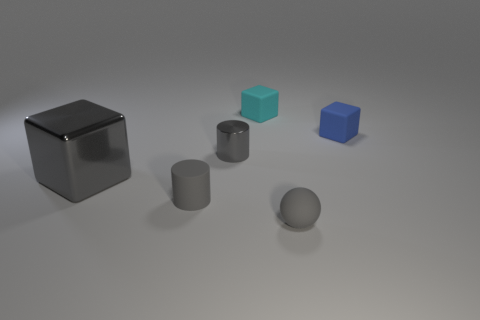There is a shiny block that is the same color as the tiny matte cylinder; what size is it?
Offer a terse response. Large. What number of shiny objects are behind the rubber block that is to the right of the small rubber object that is behind the blue thing?
Provide a succinct answer. 0. Is the color of the large metallic thing the same as the cube behind the blue rubber object?
Provide a short and direct response. No. What is the shape of the tiny rubber object that is the same color as the tiny rubber ball?
Give a very brief answer. Cylinder. What is the cube that is in front of the small gray thing that is behind the gray matte object that is left of the gray rubber sphere made of?
Your answer should be very brief. Metal. There is a gray metallic thing that is to the right of the metallic block; is it the same shape as the tiny cyan rubber object?
Ensure brevity in your answer.  No. There is a tiny object that is behind the blue matte block; what material is it?
Make the answer very short. Rubber. What number of metal objects are blue cylinders or tiny gray spheres?
Offer a terse response. 0. Is there a matte block of the same size as the gray metal cube?
Ensure brevity in your answer.  No. Are there more blue objects on the left side of the large shiny object than small blue matte things?
Give a very brief answer. No. 